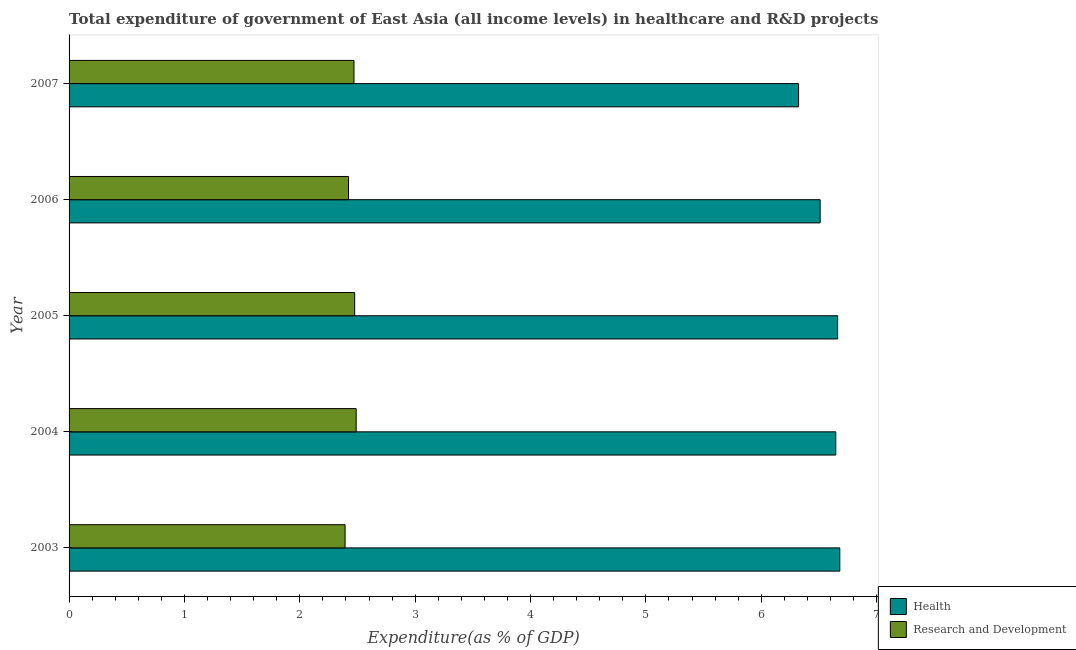How many different coloured bars are there?
Keep it short and to the point. 2. Are the number of bars per tick equal to the number of legend labels?
Your response must be concise. Yes. How many bars are there on the 5th tick from the bottom?
Your answer should be very brief. 2. What is the label of the 1st group of bars from the top?
Provide a short and direct response. 2007. In how many cases, is the number of bars for a given year not equal to the number of legend labels?
Ensure brevity in your answer.  0. What is the expenditure in r&d in 2007?
Provide a succinct answer. 2.47. Across all years, what is the maximum expenditure in r&d?
Make the answer very short. 2.49. Across all years, what is the minimum expenditure in r&d?
Make the answer very short. 2.39. In which year was the expenditure in healthcare minimum?
Your response must be concise. 2007. What is the total expenditure in r&d in the graph?
Your answer should be compact. 12.25. What is the difference between the expenditure in healthcare in 2004 and that in 2007?
Provide a short and direct response. 0.32. What is the difference between the expenditure in r&d in 2003 and the expenditure in healthcare in 2006?
Provide a succinct answer. -4.12. What is the average expenditure in healthcare per year?
Provide a short and direct response. 6.57. In the year 2004, what is the difference between the expenditure in healthcare and expenditure in r&d?
Provide a short and direct response. 4.16. In how many years, is the expenditure in r&d greater than 2.6 %?
Offer a very short reply. 0. What is the ratio of the expenditure in healthcare in 2003 to that in 2006?
Keep it short and to the point. 1.03. Is the expenditure in r&d in 2003 less than that in 2007?
Your answer should be very brief. Yes. What is the difference between the highest and the second highest expenditure in healthcare?
Provide a short and direct response. 0.02. What is the difference between the highest and the lowest expenditure in healthcare?
Ensure brevity in your answer.  0.36. In how many years, is the expenditure in r&d greater than the average expenditure in r&d taken over all years?
Ensure brevity in your answer.  3. Is the sum of the expenditure in healthcare in 2004 and 2005 greater than the maximum expenditure in r&d across all years?
Offer a very short reply. Yes. What does the 1st bar from the top in 2007 represents?
Provide a short and direct response. Research and Development. What does the 2nd bar from the bottom in 2006 represents?
Provide a short and direct response. Research and Development. What is the difference between two consecutive major ticks on the X-axis?
Offer a terse response. 1. Are the values on the major ticks of X-axis written in scientific E-notation?
Your answer should be very brief. No. Does the graph contain grids?
Your answer should be compact. No. How many legend labels are there?
Make the answer very short. 2. What is the title of the graph?
Keep it short and to the point. Total expenditure of government of East Asia (all income levels) in healthcare and R&D projects. Does "Arms exports" appear as one of the legend labels in the graph?
Your answer should be compact. No. What is the label or title of the X-axis?
Provide a succinct answer. Expenditure(as % of GDP). What is the label or title of the Y-axis?
Your answer should be very brief. Year. What is the Expenditure(as % of GDP) of Health in 2003?
Your answer should be compact. 6.68. What is the Expenditure(as % of GDP) in Research and Development in 2003?
Offer a very short reply. 2.39. What is the Expenditure(as % of GDP) of Health in 2004?
Keep it short and to the point. 6.65. What is the Expenditure(as % of GDP) in Research and Development in 2004?
Provide a short and direct response. 2.49. What is the Expenditure(as % of GDP) of Health in 2005?
Your answer should be very brief. 6.66. What is the Expenditure(as % of GDP) of Research and Development in 2005?
Make the answer very short. 2.48. What is the Expenditure(as % of GDP) of Health in 2006?
Provide a succinct answer. 6.51. What is the Expenditure(as % of GDP) of Research and Development in 2006?
Your response must be concise. 2.42. What is the Expenditure(as % of GDP) in Health in 2007?
Your answer should be very brief. 6.32. What is the Expenditure(as % of GDP) in Research and Development in 2007?
Provide a short and direct response. 2.47. Across all years, what is the maximum Expenditure(as % of GDP) of Health?
Provide a short and direct response. 6.68. Across all years, what is the maximum Expenditure(as % of GDP) of Research and Development?
Ensure brevity in your answer.  2.49. Across all years, what is the minimum Expenditure(as % of GDP) in Health?
Offer a very short reply. 6.32. Across all years, what is the minimum Expenditure(as % of GDP) of Research and Development?
Your response must be concise. 2.39. What is the total Expenditure(as % of GDP) in Health in the graph?
Your answer should be compact. 32.82. What is the total Expenditure(as % of GDP) in Research and Development in the graph?
Offer a very short reply. 12.25. What is the difference between the Expenditure(as % of GDP) in Health in 2003 and that in 2004?
Give a very brief answer. 0.04. What is the difference between the Expenditure(as % of GDP) in Research and Development in 2003 and that in 2004?
Ensure brevity in your answer.  -0.1. What is the difference between the Expenditure(as % of GDP) of Health in 2003 and that in 2005?
Your answer should be compact. 0.02. What is the difference between the Expenditure(as % of GDP) in Research and Development in 2003 and that in 2005?
Ensure brevity in your answer.  -0.08. What is the difference between the Expenditure(as % of GDP) of Health in 2003 and that in 2006?
Your response must be concise. 0.17. What is the difference between the Expenditure(as % of GDP) of Research and Development in 2003 and that in 2006?
Ensure brevity in your answer.  -0.03. What is the difference between the Expenditure(as % of GDP) of Health in 2003 and that in 2007?
Your response must be concise. 0.36. What is the difference between the Expenditure(as % of GDP) in Research and Development in 2003 and that in 2007?
Your answer should be compact. -0.08. What is the difference between the Expenditure(as % of GDP) of Health in 2004 and that in 2005?
Offer a terse response. -0.02. What is the difference between the Expenditure(as % of GDP) in Research and Development in 2004 and that in 2005?
Offer a very short reply. 0.01. What is the difference between the Expenditure(as % of GDP) in Health in 2004 and that in 2006?
Ensure brevity in your answer.  0.14. What is the difference between the Expenditure(as % of GDP) in Research and Development in 2004 and that in 2006?
Your answer should be compact. 0.07. What is the difference between the Expenditure(as % of GDP) in Health in 2004 and that in 2007?
Your answer should be compact. 0.32. What is the difference between the Expenditure(as % of GDP) of Research and Development in 2004 and that in 2007?
Offer a terse response. 0.02. What is the difference between the Expenditure(as % of GDP) in Health in 2005 and that in 2006?
Your response must be concise. 0.15. What is the difference between the Expenditure(as % of GDP) of Research and Development in 2005 and that in 2006?
Offer a very short reply. 0.05. What is the difference between the Expenditure(as % of GDP) of Health in 2005 and that in 2007?
Make the answer very short. 0.34. What is the difference between the Expenditure(as % of GDP) of Research and Development in 2005 and that in 2007?
Offer a very short reply. 0.01. What is the difference between the Expenditure(as % of GDP) of Health in 2006 and that in 2007?
Provide a succinct answer. 0.19. What is the difference between the Expenditure(as % of GDP) in Research and Development in 2006 and that in 2007?
Keep it short and to the point. -0.05. What is the difference between the Expenditure(as % of GDP) in Health in 2003 and the Expenditure(as % of GDP) in Research and Development in 2004?
Keep it short and to the point. 4.19. What is the difference between the Expenditure(as % of GDP) of Health in 2003 and the Expenditure(as % of GDP) of Research and Development in 2005?
Give a very brief answer. 4.21. What is the difference between the Expenditure(as % of GDP) in Health in 2003 and the Expenditure(as % of GDP) in Research and Development in 2006?
Your answer should be very brief. 4.26. What is the difference between the Expenditure(as % of GDP) in Health in 2003 and the Expenditure(as % of GDP) in Research and Development in 2007?
Provide a succinct answer. 4.21. What is the difference between the Expenditure(as % of GDP) of Health in 2004 and the Expenditure(as % of GDP) of Research and Development in 2005?
Your answer should be compact. 4.17. What is the difference between the Expenditure(as % of GDP) in Health in 2004 and the Expenditure(as % of GDP) in Research and Development in 2006?
Provide a short and direct response. 4.22. What is the difference between the Expenditure(as % of GDP) of Health in 2004 and the Expenditure(as % of GDP) of Research and Development in 2007?
Offer a terse response. 4.18. What is the difference between the Expenditure(as % of GDP) in Health in 2005 and the Expenditure(as % of GDP) in Research and Development in 2006?
Keep it short and to the point. 4.24. What is the difference between the Expenditure(as % of GDP) of Health in 2005 and the Expenditure(as % of GDP) of Research and Development in 2007?
Give a very brief answer. 4.19. What is the difference between the Expenditure(as % of GDP) of Health in 2006 and the Expenditure(as % of GDP) of Research and Development in 2007?
Provide a succinct answer. 4.04. What is the average Expenditure(as % of GDP) in Health per year?
Provide a short and direct response. 6.56. What is the average Expenditure(as % of GDP) of Research and Development per year?
Give a very brief answer. 2.45. In the year 2003, what is the difference between the Expenditure(as % of GDP) in Health and Expenditure(as % of GDP) in Research and Development?
Keep it short and to the point. 4.29. In the year 2004, what is the difference between the Expenditure(as % of GDP) of Health and Expenditure(as % of GDP) of Research and Development?
Give a very brief answer. 4.16. In the year 2005, what is the difference between the Expenditure(as % of GDP) in Health and Expenditure(as % of GDP) in Research and Development?
Keep it short and to the point. 4.19. In the year 2006, what is the difference between the Expenditure(as % of GDP) of Health and Expenditure(as % of GDP) of Research and Development?
Make the answer very short. 4.09. In the year 2007, what is the difference between the Expenditure(as % of GDP) in Health and Expenditure(as % of GDP) in Research and Development?
Ensure brevity in your answer.  3.85. What is the ratio of the Expenditure(as % of GDP) in Health in 2003 to that in 2004?
Make the answer very short. 1.01. What is the ratio of the Expenditure(as % of GDP) of Research and Development in 2003 to that in 2004?
Your answer should be compact. 0.96. What is the ratio of the Expenditure(as % of GDP) in Research and Development in 2003 to that in 2005?
Give a very brief answer. 0.97. What is the ratio of the Expenditure(as % of GDP) in Health in 2003 to that in 2006?
Offer a terse response. 1.03. What is the ratio of the Expenditure(as % of GDP) of Health in 2003 to that in 2007?
Provide a short and direct response. 1.06. What is the ratio of the Expenditure(as % of GDP) of Research and Development in 2003 to that in 2007?
Ensure brevity in your answer.  0.97. What is the ratio of the Expenditure(as % of GDP) of Health in 2004 to that in 2006?
Provide a succinct answer. 1.02. What is the ratio of the Expenditure(as % of GDP) in Research and Development in 2004 to that in 2006?
Provide a succinct answer. 1.03. What is the ratio of the Expenditure(as % of GDP) of Health in 2004 to that in 2007?
Ensure brevity in your answer.  1.05. What is the ratio of the Expenditure(as % of GDP) in Research and Development in 2004 to that in 2007?
Your response must be concise. 1.01. What is the ratio of the Expenditure(as % of GDP) in Health in 2005 to that in 2006?
Your answer should be very brief. 1.02. What is the ratio of the Expenditure(as % of GDP) in Research and Development in 2005 to that in 2006?
Your answer should be compact. 1.02. What is the ratio of the Expenditure(as % of GDP) of Health in 2005 to that in 2007?
Your answer should be compact. 1.05. What is the ratio of the Expenditure(as % of GDP) in Health in 2006 to that in 2007?
Ensure brevity in your answer.  1.03. What is the ratio of the Expenditure(as % of GDP) of Research and Development in 2006 to that in 2007?
Ensure brevity in your answer.  0.98. What is the difference between the highest and the second highest Expenditure(as % of GDP) in Health?
Offer a very short reply. 0.02. What is the difference between the highest and the second highest Expenditure(as % of GDP) in Research and Development?
Your answer should be very brief. 0.01. What is the difference between the highest and the lowest Expenditure(as % of GDP) in Health?
Your response must be concise. 0.36. What is the difference between the highest and the lowest Expenditure(as % of GDP) of Research and Development?
Make the answer very short. 0.1. 